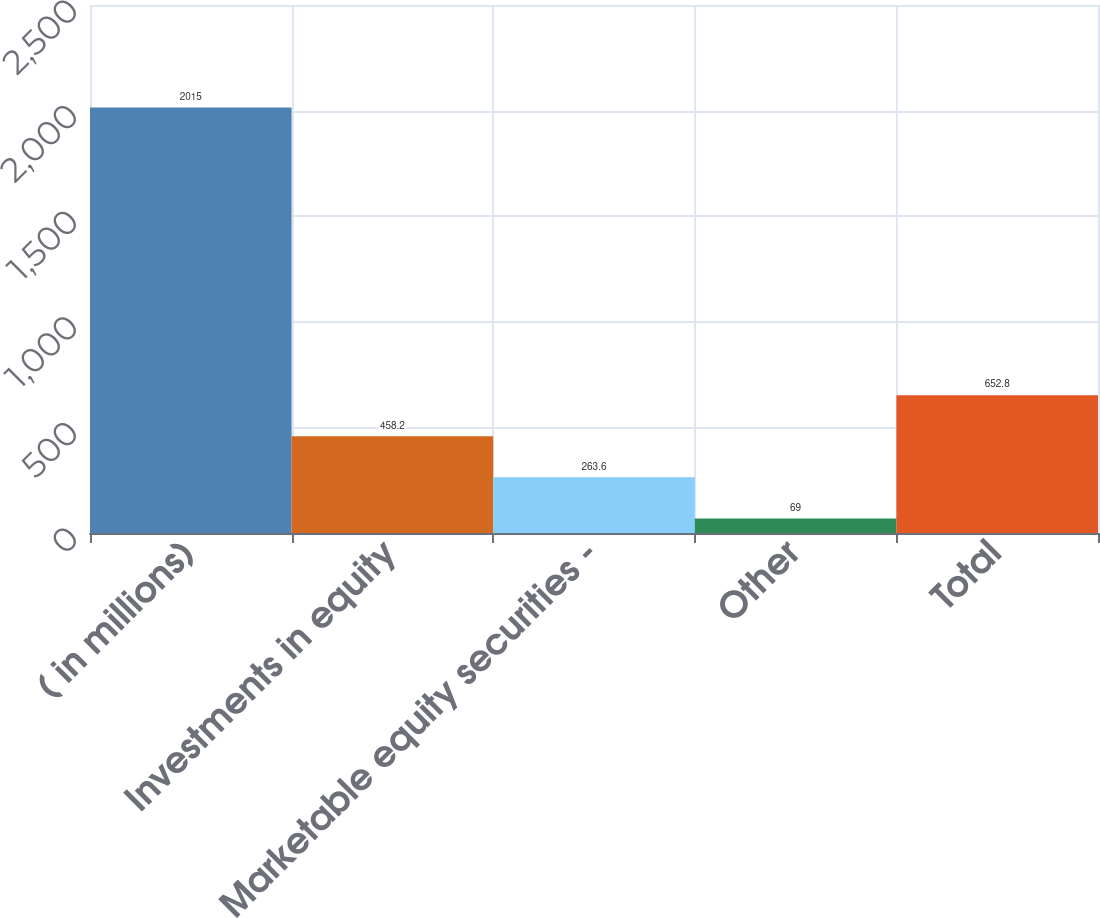<chart> <loc_0><loc_0><loc_500><loc_500><bar_chart><fcel>( in millions)<fcel>Investments in equity<fcel>Marketable equity securities -<fcel>Other<fcel>Total<nl><fcel>2015<fcel>458.2<fcel>263.6<fcel>69<fcel>652.8<nl></chart> 